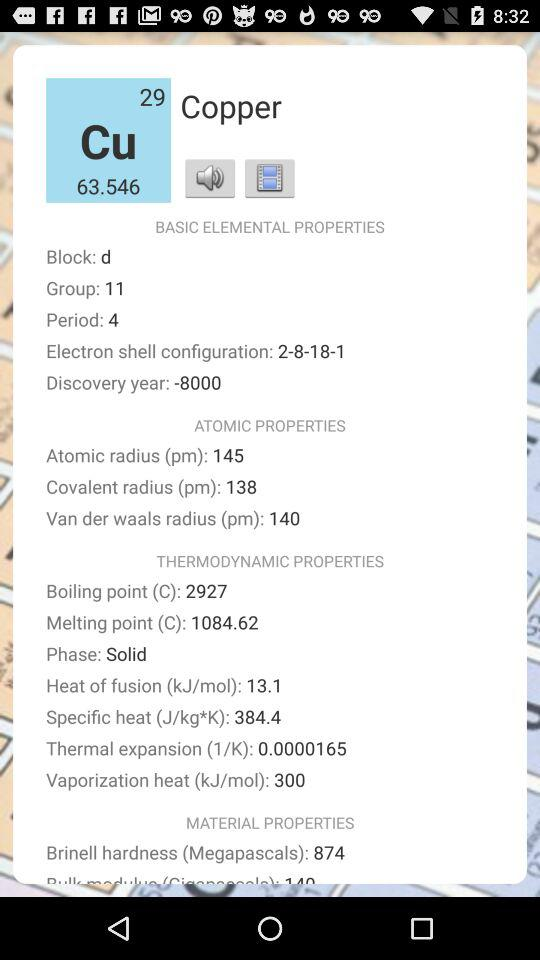What is the number of the group? The number of the group is 11. 